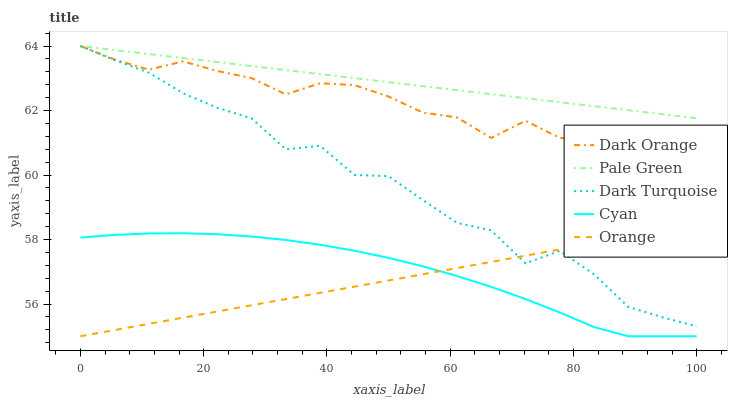Does Orange have the minimum area under the curve?
Answer yes or no. Yes. Does Pale Green have the maximum area under the curve?
Answer yes or no. Yes. Does Dark Orange have the minimum area under the curve?
Answer yes or no. No. Does Dark Orange have the maximum area under the curve?
Answer yes or no. No. Is Orange the smoothest?
Answer yes or no. Yes. Is Dark Turquoise the roughest?
Answer yes or no. Yes. Is Dark Orange the smoothest?
Answer yes or no. No. Is Dark Orange the roughest?
Answer yes or no. No. Does Orange have the lowest value?
Answer yes or no. Yes. Does Dark Orange have the lowest value?
Answer yes or no. No. Does Dark Turquoise have the highest value?
Answer yes or no. Yes. Does Cyan have the highest value?
Answer yes or no. No. Is Orange less than Pale Green?
Answer yes or no. Yes. Is Pale Green greater than Cyan?
Answer yes or no. Yes. Does Dark Orange intersect Pale Green?
Answer yes or no. Yes. Is Dark Orange less than Pale Green?
Answer yes or no. No. Is Dark Orange greater than Pale Green?
Answer yes or no. No. Does Orange intersect Pale Green?
Answer yes or no. No. 